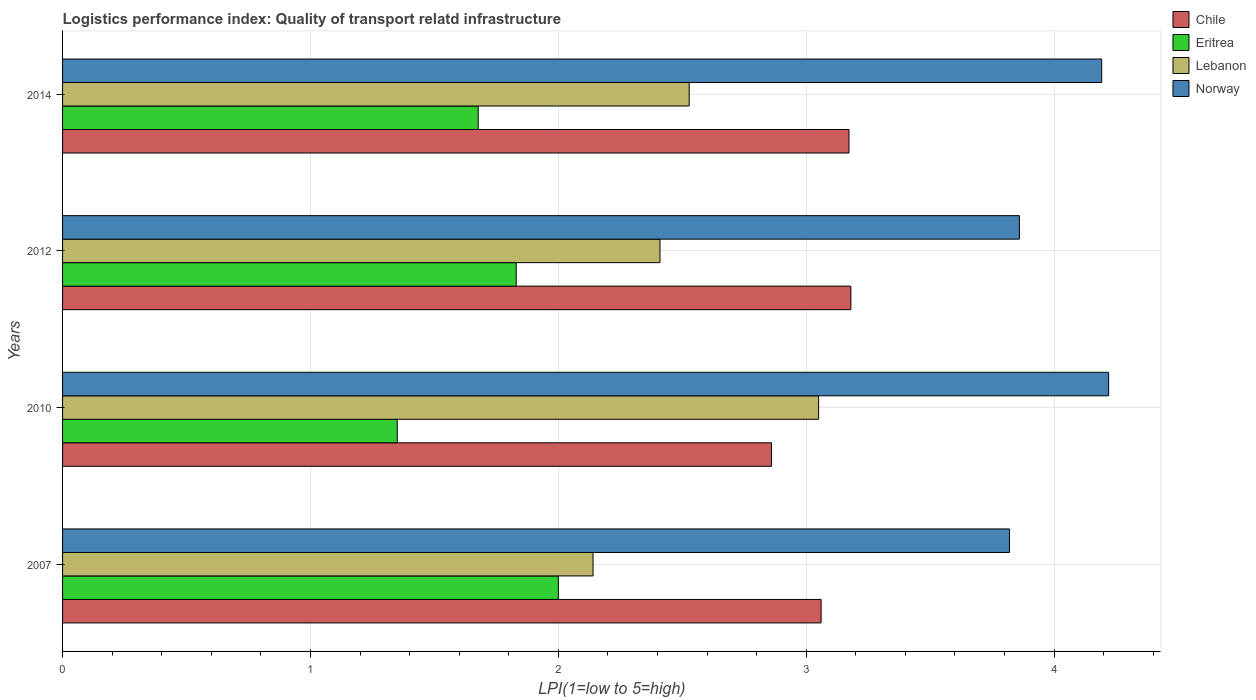How many groups of bars are there?
Ensure brevity in your answer.  4. Are the number of bars per tick equal to the number of legend labels?
Provide a short and direct response. Yes. How many bars are there on the 4th tick from the top?
Ensure brevity in your answer.  4. In how many cases, is the number of bars for a given year not equal to the number of legend labels?
Offer a terse response. 0. What is the logistics performance index in Eritrea in 2014?
Offer a very short reply. 1.68. Across all years, what is the maximum logistics performance index in Norway?
Offer a very short reply. 4.22. Across all years, what is the minimum logistics performance index in Norway?
Your answer should be very brief. 3.82. What is the total logistics performance index in Chile in the graph?
Offer a very short reply. 12.27. What is the difference between the logistics performance index in Eritrea in 2007 and that in 2010?
Provide a short and direct response. 0.65. What is the difference between the logistics performance index in Chile in 2014 and the logistics performance index in Norway in 2007?
Give a very brief answer. -0.65. What is the average logistics performance index in Chile per year?
Ensure brevity in your answer.  3.07. In the year 2007, what is the difference between the logistics performance index in Chile and logistics performance index in Eritrea?
Ensure brevity in your answer.  1.06. What is the ratio of the logistics performance index in Chile in 2010 to that in 2012?
Keep it short and to the point. 0.9. Is the logistics performance index in Lebanon in 2007 less than that in 2014?
Give a very brief answer. Yes. What is the difference between the highest and the second highest logistics performance index in Norway?
Your answer should be very brief. 0.03. What is the difference between the highest and the lowest logistics performance index in Chile?
Your answer should be compact. 0.32. In how many years, is the logistics performance index in Norway greater than the average logistics performance index in Norway taken over all years?
Provide a short and direct response. 2. Is it the case that in every year, the sum of the logistics performance index in Eritrea and logistics performance index in Norway is greater than the sum of logistics performance index in Chile and logistics performance index in Lebanon?
Your answer should be compact. Yes. What does the 2nd bar from the top in 2007 represents?
Your answer should be compact. Lebanon. What does the 2nd bar from the bottom in 2012 represents?
Ensure brevity in your answer.  Eritrea. Is it the case that in every year, the sum of the logistics performance index in Lebanon and logistics performance index in Chile is greater than the logistics performance index in Norway?
Offer a terse response. Yes. How many years are there in the graph?
Make the answer very short. 4. Are the values on the major ticks of X-axis written in scientific E-notation?
Ensure brevity in your answer.  No. Does the graph contain any zero values?
Keep it short and to the point. No. How are the legend labels stacked?
Ensure brevity in your answer.  Vertical. What is the title of the graph?
Give a very brief answer. Logistics performance index: Quality of transport relatd infrastructure. Does "Georgia" appear as one of the legend labels in the graph?
Your answer should be compact. No. What is the label or title of the X-axis?
Keep it short and to the point. LPI(1=low to 5=high). What is the LPI(1=low to 5=high) of Chile in 2007?
Provide a short and direct response. 3.06. What is the LPI(1=low to 5=high) in Lebanon in 2007?
Ensure brevity in your answer.  2.14. What is the LPI(1=low to 5=high) in Norway in 2007?
Your answer should be compact. 3.82. What is the LPI(1=low to 5=high) of Chile in 2010?
Make the answer very short. 2.86. What is the LPI(1=low to 5=high) in Eritrea in 2010?
Keep it short and to the point. 1.35. What is the LPI(1=low to 5=high) of Lebanon in 2010?
Provide a succinct answer. 3.05. What is the LPI(1=low to 5=high) in Norway in 2010?
Your response must be concise. 4.22. What is the LPI(1=low to 5=high) of Chile in 2012?
Offer a terse response. 3.18. What is the LPI(1=low to 5=high) of Eritrea in 2012?
Provide a short and direct response. 1.83. What is the LPI(1=low to 5=high) in Lebanon in 2012?
Your answer should be very brief. 2.41. What is the LPI(1=low to 5=high) in Norway in 2012?
Offer a very short reply. 3.86. What is the LPI(1=low to 5=high) of Chile in 2014?
Your answer should be compact. 3.17. What is the LPI(1=low to 5=high) of Eritrea in 2014?
Your answer should be compact. 1.68. What is the LPI(1=low to 5=high) in Lebanon in 2014?
Your answer should be very brief. 2.53. What is the LPI(1=low to 5=high) of Norway in 2014?
Ensure brevity in your answer.  4.19. Across all years, what is the maximum LPI(1=low to 5=high) of Chile?
Offer a very short reply. 3.18. Across all years, what is the maximum LPI(1=low to 5=high) in Lebanon?
Your answer should be compact. 3.05. Across all years, what is the maximum LPI(1=low to 5=high) in Norway?
Offer a terse response. 4.22. Across all years, what is the minimum LPI(1=low to 5=high) in Chile?
Keep it short and to the point. 2.86. Across all years, what is the minimum LPI(1=low to 5=high) of Eritrea?
Your response must be concise. 1.35. Across all years, what is the minimum LPI(1=low to 5=high) of Lebanon?
Give a very brief answer. 2.14. Across all years, what is the minimum LPI(1=low to 5=high) in Norway?
Make the answer very short. 3.82. What is the total LPI(1=low to 5=high) in Chile in the graph?
Offer a terse response. 12.27. What is the total LPI(1=low to 5=high) of Eritrea in the graph?
Provide a succinct answer. 6.86. What is the total LPI(1=low to 5=high) of Lebanon in the graph?
Your answer should be compact. 10.13. What is the total LPI(1=low to 5=high) in Norway in the graph?
Provide a short and direct response. 16.09. What is the difference between the LPI(1=low to 5=high) of Chile in 2007 and that in 2010?
Offer a very short reply. 0.2. What is the difference between the LPI(1=low to 5=high) of Eritrea in 2007 and that in 2010?
Provide a succinct answer. 0.65. What is the difference between the LPI(1=low to 5=high) in Lebanon in 2007 and that in 2010?
Make the answer very short. -0.91. What is the difference between the LPI(1=low to 5=high) in Norway in 2007 and that in 2010?
Offer a terse response. -0.4. What is the difference between the LPI(1=low to 5=high) of Chile in 2007 and that in 2012?
Keep it short and to the point. -0.12. What is the difference between the LPI(1=low to 5=high) of Eritrea in 2007 and that in 2012?
Keep it short and to the point. 0.17. What is the difference between the LPI(1=low to 5=high) of Lebanon in 2007 and that in 2012?
Provide a short and direct response. -0.27. What is the difference between the LPI(1=low to 5=high) in Norway in 2007 and that in 2012?
Provide a short and direct response. -0.04. What is the difference between the LPI(1=low to 5=high) of Chile in 2007 and that in 2014?
Provide a succinct answer. -0.11. What is the difference between the LPI(1=low to 5=high) in Eritrea in 2007 and that in 2014?
Offer a terse response. 0.32. What is the difference between the LPI(1=low to 5=high) in Lebanon in 2007 and that in 2014?
Make the answer very short. -0.39. What is the difference between the LPI(1=low to 5=high) in Norway in 2007 and that in 2014?
Your answer should be compact. -0.37. What is the difference between the LPI(1=low to 5=high) in Chile in 2010 and that in 2012?
Ensure brevity in your answer.  -0.32. What is the difference between the LPI(1=low to 5=high) in Eritrea in 2010 and that in 2012?
Offer a very short reply. -0.48. What is the difference between the LPI(1=low to 5=high) in Lebanon in 2010 and that in 2012?
Provide a short and direct response. 0.64. What is the difference between the LPI(1=low to 5=high) of Norway in 2010 and that in 2012?
Offer a terse response. 0.36. What is the difference between the LPI(1=low to 5=high) in Chile in 2010 and that in 2014?
Give a very brief answer. -0.31. What is the difference between the LPI(1=low to 5=high) of Eritrea in 2010 and that in 2014?
Provide a short and direct response. -0.33. What is the difference between the LPI(1=low to 5=high) in Lebanon in 2010 and that in 2014?
Your answer should be compact. 0.52. What is the difference between the LPI(1=low to 5=high) of Norway in 2010 and that in 2014?
Offer a very short reply. 0.03. What is the difference between the LPI(1=low to 5=high) of Chile in 2012 and that in 2014?
Provide a short and direct response. 0.01. What is the difference between the LPI(1=low to 5=high) of Eritrea in 2012 and that in 2014?
Make the answer very short. 0.15. What is the difference between the LPI(1=low to 5=high) of Lebanon in 2012 and that in 2014?
Your answer should be compact. -0.12. What is the difference between the LPI(1=low to 5=high) in Norway in 2012 and that in 2014?
Offer a very short reply. -0.33. What is the difference between the LPI(1=low to 5=high) of Chile in 2007 and the LPI(1=low to 5=high) of Eritrea in 2010?
Your response must be concise. 1.71. What is the difference between the LPI(1=low to 5=high) of Chile in 2007 and the LPI(1=low to 5=high) of Norway in 2010?
Give a very brief answer. -1.16. What is the difference between the LPI(1=low to 5=high) of Eritrea in 2007 and the LPI(1=low to 5=high) of Lebanon in 2010?
Provide a short and direct response. -1.05. What is the difference between the LPI(1=low to 5=high) of Eritrea in 2007 and the LPI(1=low to 5=high) of Norway in 2010?
Give a very brief answer. -2.22. What is the difference between the LPI(1=low to 5=high) of Lebanon in 2007 and the LPI(1=low to 5=high) of Norway in 2010?
Provide a succinct answer. -2.08. What is the difference between the LPI(1=low to 5=high) of Chile in 2007 and the LPI(1=low to 5=high) of Eritrea in 2012?
Offer a very short reply. 1.23. What is the difference between the LPI(1=low to 5=high) of Chile in 2007 and the LPI(1=low to 5=high) of Lebanon in 2012?
Your answer should be compact. 0.65. What is the difference between the LPI(1=low to 5=high) of Eritrea in 2007 and the LPI(1=low to 5=high) of Lebanon in 2012?
Your answer should be compact. -0.41. What is the difference between the LPI(1=low to 5=high) in Eritrea in 2007 and the LPI(1=low to 5=high) in Norway in 2012?
Give a very brief answer. -1.86. What is the difference between the LPI(1=low to 5=high) in Lebanon in 2007 and the LPI(1=low to 5=high) in Norway in 2012?
Your response must be concise. -1.72. What is the difference between the LPI(1=low to 5=high) in Chile in 2007 and the LPI(1=low to 5=high) in Eritrea in 2014?
Make the answer very short. 1.38. What is the difference between the LPI(1=low to 5=high) in Chile in 2007 and the LPI(1=low to 5=high) in Lebanon in 2014?
Offer a terse response. 0.53. What is the difference between the LPI(1=low to 5=high) of Chile in 2007 and the LPI(1=low to 5=high) of Norway in 2014?
Keep it short and to the point. -1.13. What is the difference between the LPI(1=low to 5=high) in Eritrea in 2007 and the LPI(1=low to 5=high) in Lebanon in 2014?
Offer a terse response. -0.53. What is the difference between the LPI(1=low to 5=high) in Eritrea in 2007 and the LPI(1=low to 5=high) in Norway in 2014?
Your answer should be compact. -2.19. What is the difference between the LPI(1=low to 5=high) in Lebanon in 2007 and the LPI(1=low to 5=high) in Norway in 2014?
Your answer should be very brief. -2.05. What is the difference between the LPI(1=low to 5=high) of Chile in 2010 and the LPI(1=low to 5=high) of Lebanon in 2012?
Ensure brevity in your answer.  0.45. What is the difference between the LPI(1=low to 5=high) of Chile in 2010 and the LPI(1=low to 5=high) of Norway in 2012?
Offer a very short reply. -1. What is the difference between the LPI(1=low to 5=high) in Eritrea in 2010 and the LPI(1=low to 5=high) in Lebanon in 2012?
Your answer should be very brief. -1.06. What is the difference between the LPI(1=low to 5=high) in Eritrea in 2010 and the LPI(1=low to 5=high) in Norway in 2012?
Your answer should be very brief. -2.51. What is the difference between the LPI(1=low to 5=high) of Lebanon in 2010 and the LPI(1=low to 5=high) of Norway in 2012?
Make the answer very short. -0.81. What is the difference between the LPI(1=low to 5=high) in Chile in 2010 and the LPI(1=low to 5=high) in Eritrea in 2014?
Your answer should be compact. 1.18. What is the difference between the LPI(1=low to 5=high) in Chile in 2010 and the LPI(1=low to 5=high) in Lebanon in 2014?
Your response must be concise. 0.33. What is the difference between the LPI(1=low to 5=high) of Chile in 2010 and the LPI(1=low to 5=high) of Norway in 2014?
Your answer should be compact. -1.33. What is the difference between the LPI(1=low to 5=high) in Eritrea in 2010 and the LPI(1=low to 5=high) in Lebanon in 2014?
Give a very brief answer. -1.18. What is the difference between the LPI(1=low to 5=high) in Eritrea in 2010 and the LPI(1=low to 5=high) in Norway in 2014?
Ensure brevity in your answer.  -2.84. What is the difference between the LPI(1=low to 5=high) in Lebanon in 2010 and the LPI(1=low to 5=high) in Norway in 2014?
Your answer should be very brief. -1.14. What is the difference between the LPI(1=low to 5=high) of Chile in 2012 and the LPI(1=low to 5=high) of Eritrea in 2014?
Your answer should be compact. 1.5. What is the difference between the LPI(1=low to 5=high) of Chile in 2012 and the LPI(1=low to 5=high) of Lebanon in 2014?
Your answer should be very brief. 0.65. What is the difference between the LPI(1=low to 5=high) of Chile in 2012 and the LPI(1=low to 5=high) of Norway in 2014?
Offer a terse response. -1.01. What is the difference between the LPI(1=low to 5=high) in Eritrea in 2012 and the LPI(1=low to 5=high) in Lebanon in 2014?
Keep it short and to the point. -0.7. What is the difference between the LPI(1=low to 5=high) in Eritrea in 2012 and the LPI(1=low to 5=high) in Norway in 2014?
Ensure brevity in your answer.  -2.36. What is the difference between the LPI(1=low to 5=high) of Lebanon in 2012 and the LPI(1=low to 5=high) of Norway in 2014?
Your answer should be compact. -1.78. What is the average LPI(1=low to 5=high) in Chile per year?
Your answer should be very brief. 3.07. What is the average LPI(1=low to 5=high) in Eritrea per year?
Your answer should be compact. 1.71. What is the average LPI(1=low to 5=high) of Lebanon per year?
Give a very brief answer. 2.53. What is the average LPI(1=low to 5=high) of Norway per year?
Make the answer very short. 4.02. In the year 2007, what is the difference between the LPI(1=low to 5=high) of Chile and LPI(1=low to 5=high) of Eritrea?
Offer a terse response. 1.06. In the year 2007, what is the difference between the LPI(1=low to 5=high) in Chile and LPI(1=low to 5=high) in Lebanon?
Offer a very short reply. 0.92. In the year 2007, what is the difference between the LPI(1=low to 5=high) of Chile and LPI(1=low to 5=high) of Norway?
Provide a succinct answer. -0.76. In the year 2007, what is the difference between the LPI(1=low to 5=high) in Eritrea and LPI(1=low to 5=high) in Lebanon?
Keep it short and to the point. -0.14. In the year 2007, what is the difference between the LPI(1=low to 5=high) of Eritrea and LPI(1=low to 5=high) of Norway?
Your answer should be very brief. -1.82. In the year 2007, what is the difference between the LPI(1=low to 5=high) of Lebanon and LPI(1=low to 5=high) of Norway?
Your answer should be very brief. -1.68. In the year 2010, what is the difference between the LPI(1=low to 5=high) of Chile and LPI(1=low to 5=high) of Eritrea?
Your answer should be very brief. 1.51. In the year 2010, what is the difference between the LPI(1=low to 5=high) in Chile and LPI(1=low to 5=high) in Lebanon?
Keep it short and to the point. -0.19. In the year 2010, what is the difference between the LPI(1=low to 5=high) of Chile and LPI(1=low to 5=high) of Norway?
Offer a terse response. -1.36. In the year 2010, what is the difference between the LPI(1=low to 5=high) in Eritrea and LPI(1=low to 5=high) in Lebanon?
Your answer should be very brief. -1.7. In the year 2010, what is the difference between the LPI(1=low to 5=high) of Eritrea and LPI(1=low to 5=high) of Norway?
Give a very brief answer. -2.87. In the year 2010, what is the difference between the LPI(1=low to 5=high) of Lebanon and LPI(1=low to 5=high) of Norway?
Your response must be concise. -1.17. In the year 2012, what is the difference between the LPI(1=low to 5=high) of Chile and LPI(1=low to 5=high) of Eritrea?
Offer a terse response. 1.35. In the year 2012, what is the difference between the LPI(1=low to 5=high) in Chile and LPI(1=low to 5=high) in Lebanon?
Offer a terse response. 0.77. In the year 2012, what is the difference between the LPI(1=low to 5=high) of Chile and LPI(1=low to 5=high) of Norway?
Your answer should be very brief. -0.68. In the year 2012, what is the difference between the LPI(1=low to 5=high) of Eritrea and LPI(1=low to 5=high) of Lebanon?
Make the answer very short. -0.58. In the year 2012, what is the difference between the LPI(1=low to 5=high) of Eritrea and LPI(1=low to 5=high) of Norway?
Keep it short and to the point. -2.03. In the year 2012, what is the difference between the LPI(1=low to 5=high) of Lebanon and LPI(1=low to 5=high) of Norway?
Ensure brevity in your answer.  -1.45. In the year 2014, what is the difference between the LPI(1=low to 5=high) in Chile and LPI(1=low to 5=high) in Eritrea?
Your answer should be compact. 1.5. In the year 2014, what is the difference between the LPI(1=low to 5=high) of Chile and LPI(1=low to 5=high) of Lebanon?
Offer a terse response. 0.64. In the year 2014, what is the difference between the LPI(1=low to 5=high) in Chile and LPI(1=low to 5=high) in Norway?
Give a very brief answer. -1.02. In the year 2014, what is the difference between the LPI(1=low to 5=high) in Eritrea and LPI(1=low to 5=high) in Lebanon?
Your answer should be very brief. -0.85. In the year 2014, what is the difference between the LPI(1=low to 5=high) of Eritrea and LPI(1=low to 5=high) of Norway?
Your answer should be compact. -2.52. In the year 2014, what is the difference between the LPI(1=low to 5=high) of Lebanon and LPI(1=low to 5=high) of Norway?
Your answer should be very brief. -1.66. What is the ratio of the LPI(1=low to 5=high) of Chile in 2007 to that in 2010?
Ensure brevity in your answer.  1.07. What is the ratio of the LPI(1=low to 5=high) of Eritrea in 2007 to that in 2010?
Your response must be concise. 1.48. What is the ratio of the LPI(1=low to 5=high) in Lebanon in 2007 to that in 2010?
Keep it short and to the point. 0.7. What is the ratio of the LPI(1=low to 5=high) of Norway in 2007 to that in 2010?
Your answer should be compact. 0.91. What is the ratio of the LPI(1=low to 5=high) of Chile in 2007 to that in 2012?
Your answer should be very brief. 0.96. What is the ratio of the LPI(1=low to 5=high) of Eritrea in 2007 to that in 2012?
Your response must be concise. 1.09. What is the ratio of the LPI(1=low to 5=high) in Lebanon in 2007 to that in 2012?
Make the answer very short. 0.89. What is the ratio of the LPI(1=low to 5=high) in Norway in 2007 to that in 2012?
Your answer should be very brief. 0.99. What is the ratio of the LPI(1=low to 5=high) in Chile in 2007 to that in 2014?
Offer a terse response. 0.96. What is the ratio of the LPI(1=low to 5=high) in Eritrea in 2007 to that in 2014?
Provide a short and direct response. 1.19. What is the ratio of the LPI(1=low to 5=high) in Lebanon in 2007 to that in 2014?
Keep it short and to the point. 0.85. What is the ratio of the LPI(1=low to 5=high) of Norway in 2007 to that in 2014?
Offer a terse response. 0.91. What is the ratio of the LPI(1=low to 5=high) in Chile in 2010 to that in 2012?
Offer a very short reply. 0.9. What is the ratio of the LPI(1=low to 5=high) in Eritrea in 2010 to that in 2012?
Provide a short and direct response. 0.74. What is the ratio of the LPI(1=low to 5=high) in Lebanon in 2010 to that in 2012?
Provide a short and direct response. 1.27. What is the ratio of the LPI(1=low to 5=high) in Norway in 2010 to that in 2012?
Keep it short and to the point. 1.09. What is the ratio of the LPI(1=low to 5=high) of Chile in 2010 to that in 2014?
Ensure brevity in your answer.  0.9. What is the ratio of the LPI(1=low to 5=high) in Eritrea in 2010 to that in 2014?
Offer a terse response. 0.81. What is the ratio of the LPI(1=low to 5=high) in Lebanon in 2010 to that in 2014?
Your answer should be compact. 1.21. What is the ratio of the LPI(1=low to 5=high) of Chile in 2012 to that in 2014?
Offer a very short reply. 1. What is the ratio of the LPI(1=low to 5=high) of Eritrea in 2012 to that in 2014?
Provide a succinct answer. 1.09. What is the ratio of the LPI(1=low to 5=high) in Lebanon in 2012 to that in 2014?
Offer a terse response. 0.95. What is the ratio of the LPI(1=low to 5=high) of Norway in 2012 to that in 2014?
Give a very brief answer. 0.92. What is the difference between the highest and the second highest LPI(1=low to 5=high) in Chile?
Provide a short and direct response. 0.01. What is the difference between the highest and the second highest LPI(1=low to 5=high) in Eritrea?
Your answer should be very brief. 0.17. What is the difference between the highest and the second highest LPI(1=low to 5=high) of Lebanon?
Offer a terse response. 0.52. What is the difference between the highest and the second highest LPI(1=low to 5=high) of Norway?
Give a very brief answer. 0.03. What is the difference between the highest and the lowest LPI(1=low to 5=high) in Chile?
Provide a succinct answer. 0.32. What is the difference between the highest and the lowest LPI(1=low to 5=high) of Eritrea?
Your answer should be compact. 0.65. What is the difference between the highest and the lowest LPI(1=low to 5=high) of Lebanon?
Make the answer very short. 0.91. 